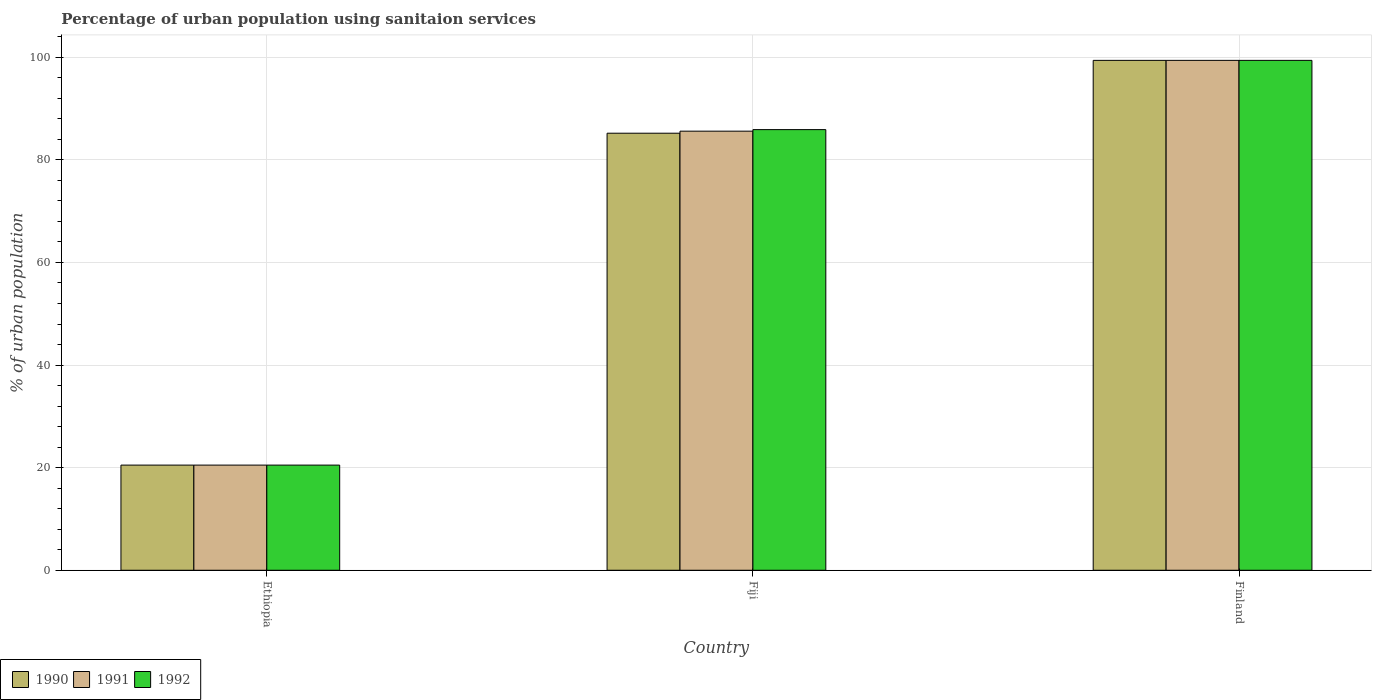How many different coloured bars are there?
Ensure brevity in your answer.  3. Are the number of bars per tick equal to the number of legend labels?
Provide a succinct answer. Yes. Are the number of bars on each tick of the X-axis equal?
Offer a very short reply. Yes. How many bars are there on the 3rd tick from the right?
Make the answer very short. 3. What is the label of the 2nd group of bars from the left?
Offer a very short reply. Fiji. In how many cases, is the number of bars for a given country not equal to the number of legend labels?
Keep it short and to the point. 0. What is the percentage of urban population using sanitaion services in 1991 in Fiji?
Make the answer very short. 85.6. Across all countries, what is the maximum percentage of urban population using sanitaion services in 1992?
Your response must be concise. 99.4. Across all countries, what is the minimum percentage of urban population using sanitaion services in 1992?
Provide a short and direct response. 20.5. In which country was the percentage of urban population using sanitaion services in 1990 maximum?
Provide a succinct answer. Finland. In which country was the percentage of urban population using sanitaion services in 1992 minimum?
Offer a terse response. Ethiopia. What is the total percentage of urban population using sanitaion services in 1990 in the graph?
Provide a succinct answer. 205.1. What is the difference between the percentage of urban population using sanitaion services in 1992 in Fiji and that in Finland?
Your answer should be compact. -13.5. What is the difference between the percentage of urban population using sanitaion services in 1991 in Ethiopia and the percentage of urban population using sanitaion services in 1990 in Fiji?
Your answer should be very brief. -64.7. What is the average percentage of urban population using sanitaion services in 1992 per country?
Offer a terse response. 68.6. What is the difference between the percentage of urban population using sanitaion services of/in 1992 and percentage of urban population using sanitaion services of/in 1990 in Finland?
Provide a succinct answer. 0. What is the ratio of the percentage of urban population using sanitaion services in 1991 in Ethiopia to that in Finland?
Keep it short and to the point. 0.21. Is the percentage of urban population using sanitaion services in 1991 in Ethiopia less than that in Fiji?
Offer a terse response. Yes. What is the difference between the highest and the second highest percentage of urban population using sanitaion services in 1992?
Give a very brief answer. 78.9. What is the difference between the highest and the lowest percentage of urban population using sanitaion services in 1992?
Provide a succinct answer. 78.9. Is the sum of the percentage of urban population using sanitaion services in 1990 in Fiji and Finland greater than the maximum percentage of urban population using sanitaion services in 1991 across all countries?
Provide a short and direct response. Yes. What does the 1st bar from the left in Finland represents?
Provide a short and direct response. 1990. How many bars are there?
Offer a very short reply. 9. Does the graph contain any zero values?
Offer a very short reply. No. Where does the legend appear in the graph?
Make the answer very short. Bottom left. How many legend labels are there?
Offer a very short reply. 3. How are the legend labels stacked?
Provide a short and direct response. Horizontal. What is the title of the graph?
Your response must be concise. Percentage of urban population using sanitaion services. Does "2001" appear as one of the legend labels in the graph?
Give a very brief answer. No. What is the label or title of the X-axis?
Give a very brief answer. Country. What is the label or title of the Y-axis?
Ensure brevity in your answer.  % of urban population. What is the % of urban population in 1990 in Fiji?
Give a very brief answer. 85.2. What is the % of urban population in 1991 in Fiji?
Offer a terse response. 85.6. What is the % of urban population in 1992 in Fiji?
Your answer should be compact. 85.9. What is the % of urban population in 1990 in Finland?
Your answer should be very brief. 99.4. What is the % of urban population in 1991 in Finland?
Provide a short and direct response. 99.4. What is the % of urban population in 1992 in Finland?
Provide a short and direct response. 99.4. Across all countries, what is the maximum % of urban population of 1990?
Offer a very short reply. 99.4. Across all countries, what is the maximum % of urban population of 1991?
Your answer should be compact. 99.4. Across all countries, what is the maximum % of urban population in 1992?
Provide a short and direct response. 99.4. Across all countries, what is the minimum % of urban population in 1990?
Keep it short and to the point. 20.5. Across all countries, what is the minimum % of urban population of 1992?
Keep it short and to the point. 20.5. What is the total % of urban population of 1990 in the graph?
Keep it short and to the point. 205.1. What is the total % of urban population of 1991 in the graph?
Your response must be concise. 205.5. What is the total % of urban population of 1992 in the graph?
Offer a terse response. 205.8. What is the difference between the % of urban population in 1990 in Ethiopia and that in Fiji?
Make the answer very short. -64.7. What is the difference between the % of urban population of 1991 in Ethiopia and that in Fiji?
Keep it short and to the point. -65.1. What is the difference between the % of urban population in 1992 in Ethiopia and that in Fiji?
Provide a succinct answer. -65.4. What is the difference between the % of urban population of 1990 in Ethiopia and that in Finland?
Offer a terse response. -78.9. What is the difference between the % of urban population of 1991 in Ethiopia and that in Finland?
Offer a very short reply. -78.9. What is the difference between the % of urban population of 1992 in Ethiopia and that in Finland?
Provide a succinct answer. -78.9. What is the difference between the % of urban population in 1991 in Fiji and that in Finland?
Give a very brief answer. -13.8. What is the difference between the % of urban population of 1990 in Ethiopia and the % of urban population of 1991 in Fiji?
Your response must be concise. -65.1. What is the difference between the % of urban population of 1990 in Ethiopia and the % of urban population of 1992 in Fiji?
Offer a very short reply. -65.4. What is the difference between the % of urban population of 1991 in Ethiopia and the % of urban population of 1992 in Fiji?
Make the answer very short. -65.4. What is the difference between the % of urban population of 1990 in Ethiopia and the % of urban population of 1991 in Finland?
Provide a succinct answer. -78.9. What is the difference between the % of urban population of 1990 in Ethiopia and the % of urban population of 1992 in Finland?
Provide a short and direct response. -78.9. What is the difference between the % of urban population of 1991 in Ethiopia and the % of urban population of 1992 in Finland?
Provide a short and direct response. -78.9. What is the difference between the % of urban population of 1990 in Fiji and the % of urban population of 1992 in Finland?
Keep it short and to the point. -14.2. What is the difference between the % of urban population in 1991 in Fiji and the % of urban population in 1992 in Finland?
Provide a short and direct response. -13.8. What is the average % of urban population in 1990 per country?
Your answer should be compact. 68.37. What is the average % of urban population in 1991 per country?
Your answer should be compact. 68.5. What is the average % of urban population of 1992 per country?
Give a very brief answer. 68.6. What is the difference between the % of urban population in 1990 and % of urban population in 1991 in Ethiopia?
Your response must be concise. 0. What is the difference between the % of urban population in 1991 and % of urban population in 1992 in Ethiopia?
Offer a very short reply. 0. What is the difference between the % of urban population in 1990 and % of urban population in 1991 in Fiji?
Keep it short and to the point. -0.4. What is the difference between the % of urban population in 1990 and % of urban population in 1992 in Fiji?
Give a very brief answer. -0.7. What is the difference between the % of urban population of 1990 and % of urban population of 1991 in Finland?
Your response must be concise. 0. What is the difference between the % of urban population of 1991 and % of urban population of 1992 in Finland?
Keep it short and to the point. 0. What is the ratio of the % of urban population in 1990 in Ethiopia to that in Fiji?
Keep it short and to the point. 0.24. What is the ratio of the % of urban population of 1991 in Ethiopia to that in Fiji?
Make the answer very short. 0.24. What is the ratio of the % of urban population in 1992 in Ethiopia to that in Fiji?
Provide a short and direct response. 0.24. What is the ratio of the % of urban population in 1990 in Ethiopia to that in Finland?
Provide a succinct answer. 0.21. What is the ratio of the % of urban population in 1991 in Ethiopia to that in Finland?
Offer a very short reply. 0.21. What is the ratio of the % of urban population of 1992 in Ethiopia to that in Finland?
Make the answer very short. 0.21. What is the ratio of the % of urban population in 1991 in Fiji to that in Finland?
Ensure brevity in your answer.  0.86. What is the ratio of the % of urban population in 1992 in Fiji to that in Finland?
Offer a very short reply. 0.86. What is the difference between the highest and the second highest % of urban population in 1990?
Make the answer very short. 14.2. What is the difference between the highest and the second highest % of urban population in 1992?
Your answer should be compact. 13.5. What is the difference between the highest and the lowest % of urban population of 1990?
Provide a succinct answer. 78.9. What is the difference between the highest and the lowest % of urban population in 1991?
Give a very brief answer. 78.9. What is the difference between the highest and the lowest % of urban population in 1992?
Provide a succinct answer. 78.9. 